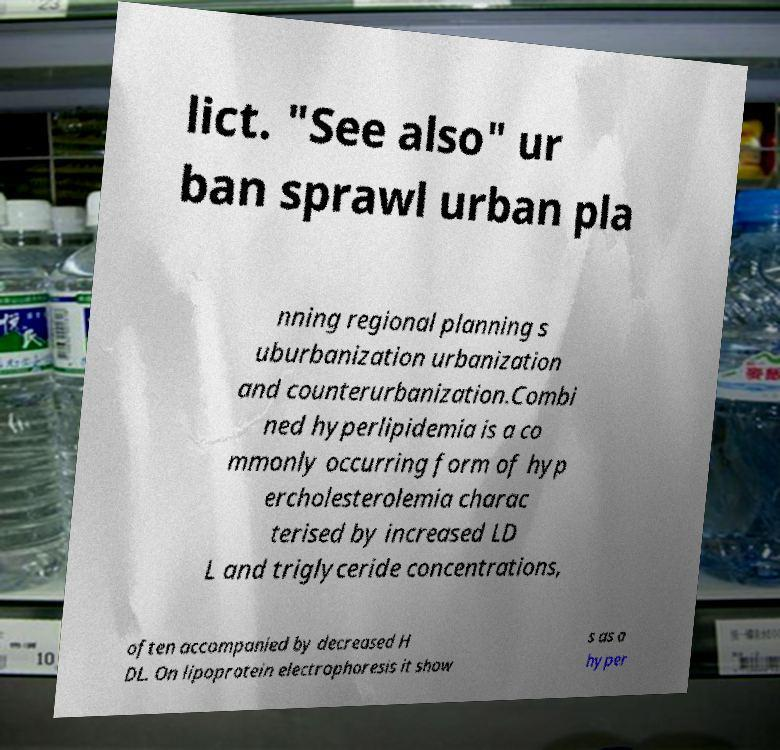Could you extract and type out the text from this image? lict. "See also" ur ban sprawl urban pla nning regional planning s uburbanization urbanization and counterurbanization.Combi ned hyperlipidemia is a co mmonly occurring form of hyp ercholesterolemia charac terised by increased LD L and triglyceride concentrations, often accompanied by decreased H DL. On lipoprotein electrophoresis it show s as a hyper 